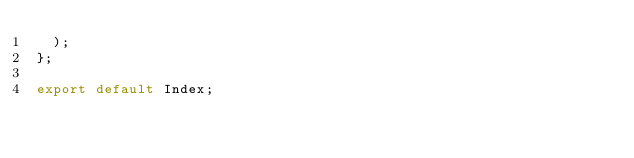Convert code to text. <code><loc_0><loc_0><loc_500><loc_500><_JavaScript_>  );
};

export default Index;
</code> 